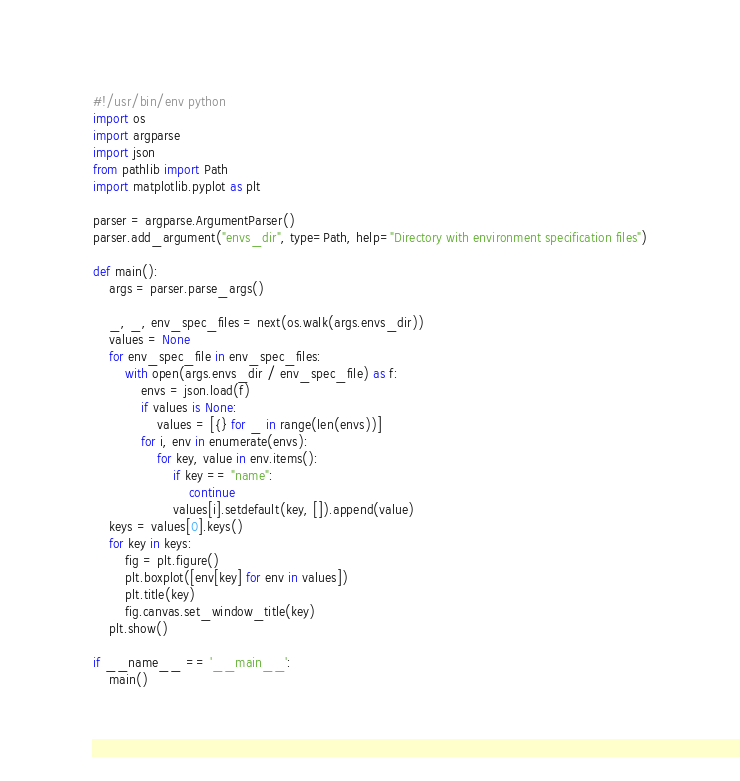<code> <loc_0><loc_0><loc_500><loc_500><_Python_>#!/usr/bin/env python
import os
import argparse
import json
from pathlib import Path
import matplotlib.pyplot as plt

parser = argparse.ArgumentParser()
parser.add_argument("envs_dir", type=Path, help="Directory with environment specification files")

def main():
    args = parser.parse_args()

    _, _, env_spec_files = next(os.walk(args.envs_dir))
    values = None
    for env_spec_file in env_spec_files:
        with open(args.envs_dir / env_spec_file) as f:
            envs = json.load(f)
            if values is None:
                values = [{} for _ in range(len(envs))]
            for i, env in enumerate(envs):
                for key, value in env.items():
                    if key == "name":
                        continue
                    values[i].setdefault(key, []).append(value)
    keys = values[0].keys()
    for key in keys:
        fig = plt.figure()
        plt.boxplot([env[key] for env in values])
        plt.title(key)
        fig.canvas.set_window_title(key)
    plt.show()

if __name__ == '__main__':
    main()
</code> 